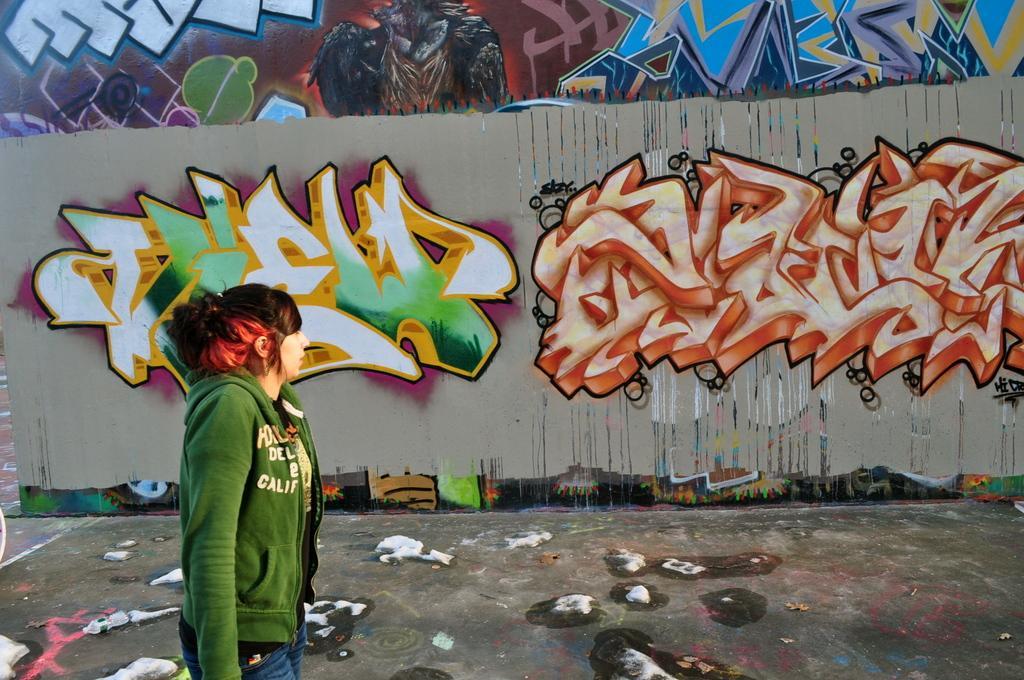Describe this image in one or two sentences. In this image, we can see a lady and in the background, we can see a graffiti on the wall. At the bottom, there is a bottle and some other objects on the road. 